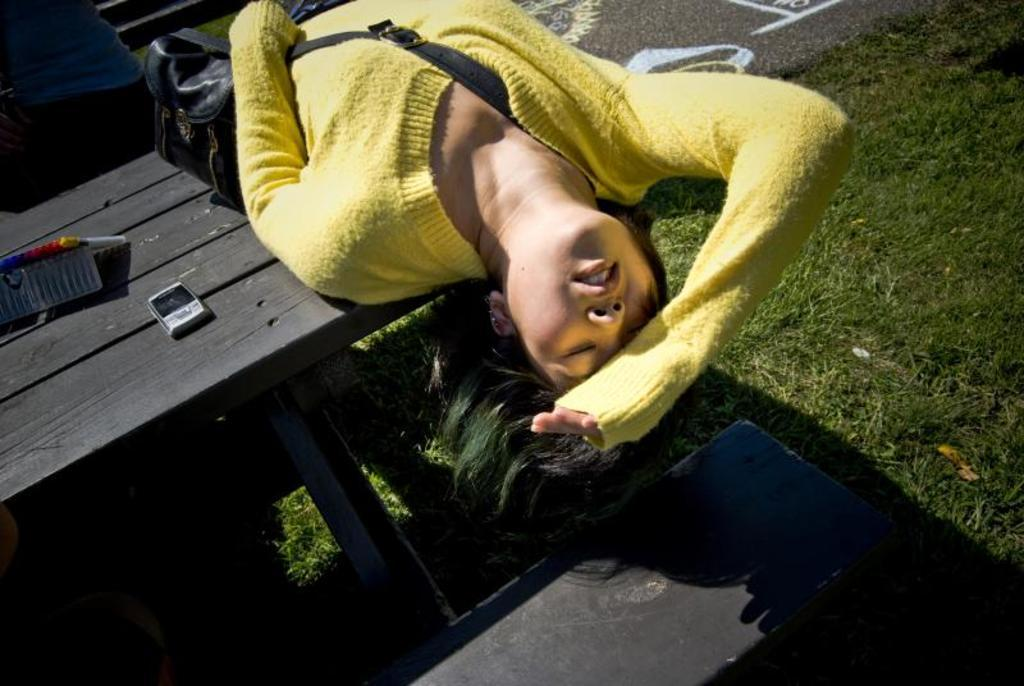What is the woman doing in the image? The woman is lying on a table in the image. What is on the table with the woman? There is a wire bag on the table. What can be seen on the bench in the image? There is a mobile and an object on the bench. What type of seed is being planted in the image? There is no seed or planting activity present in the image. How does the mobile play music in the image? The mobile does not play music in the image; it is a stationary object on the bench. 